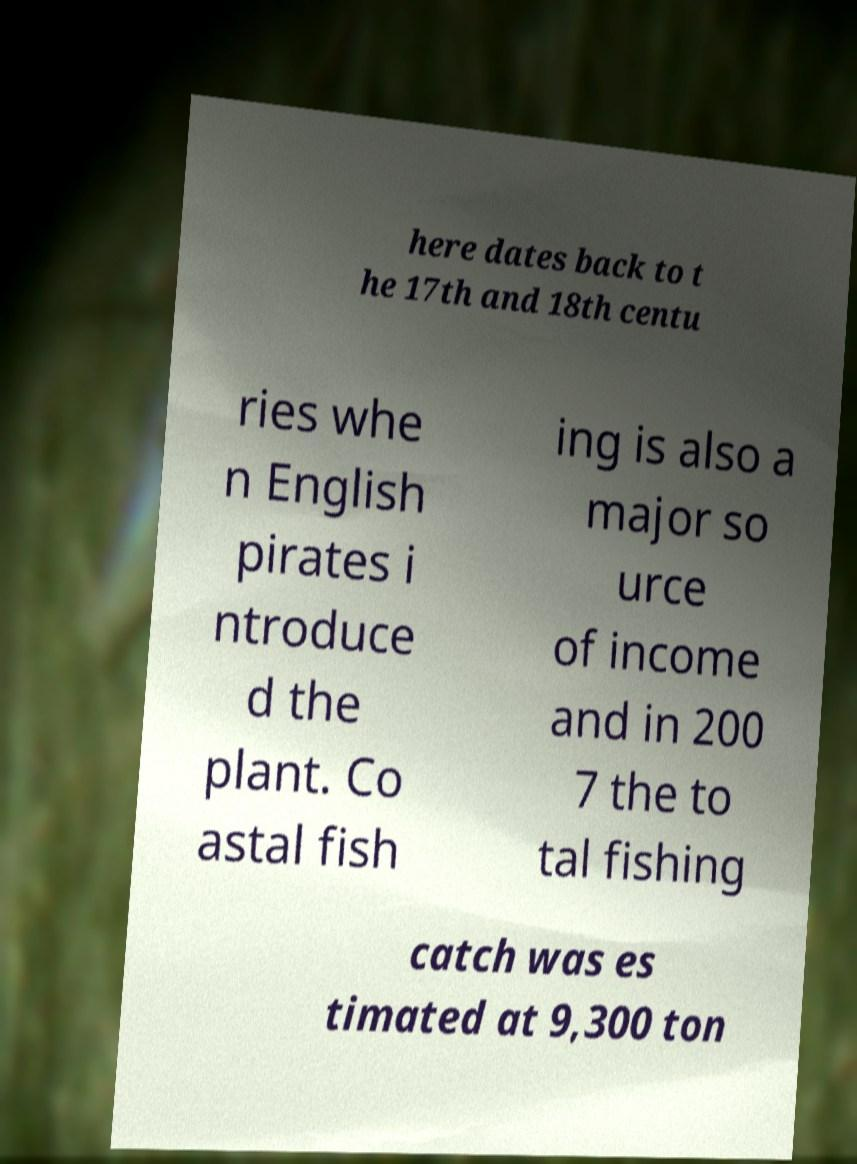I need the written content from this picture converted into text. Can you do that? here dates back to t he 17th and 18th centu ries whe n English pirates i ntroduce d the plant. Co astal fish ing is also a major so urce of income and in 200 7 the to tal fishing catch was es timated at 9,300 ton 